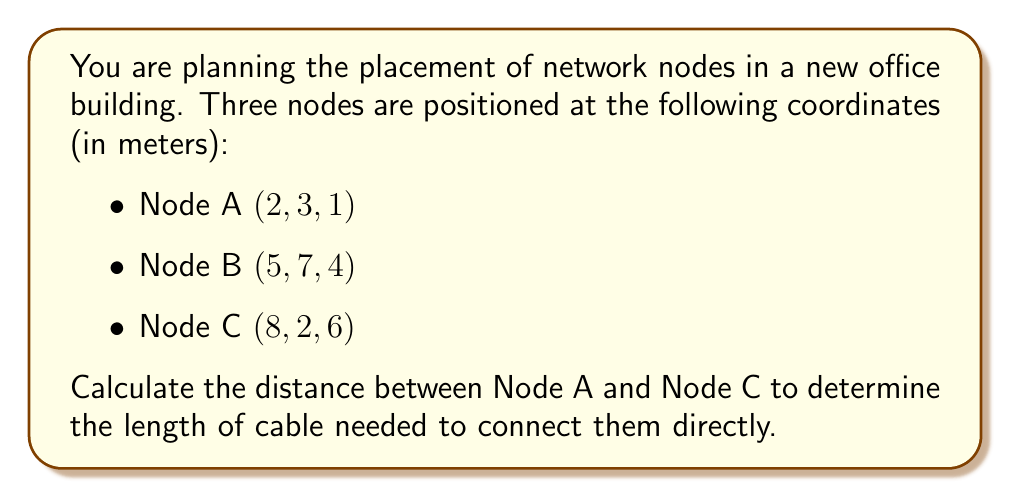Provide a solution to this math problem. To solve this problem, we need to use the distance formula in three-dimensional space. The distance $d$ between two points $(x_1, y_1, z_1)$ and $(x_2, y_2, z_2)$ in 3D space is given by:

$$d = \sqrt{(x_2 - x_1)^2 + (y_2 - y_1)^2 + (z_2 - z_1)^2}$$

Let's identify the coordinates:
- Node A: $(x_1, y_1, z_1) = (2, 3, 1)$
- Node C: $(x_2, y_2, z_2) = (8, 2, 6)$

Now, let's substitute these values into the formula:

$$\begin{aligned}
d &= \sqrt{(8 - 2)^2 + (2 - 3)^2 + (6 - 1)^2} \\
&= \sqrt{6^2 + (-1)^2 + 5^2} \\
&= \sqrt{36 + 1 + 25} \\
&= \sqrt{62} \\
&\approx 7.87 \text{ meters}
\end{aligned}$$

Therefore, the distance between Node A and Node C is approximately 7.87 meters.
Answer: $\sqrt{62} \approx 7.87$ meters 